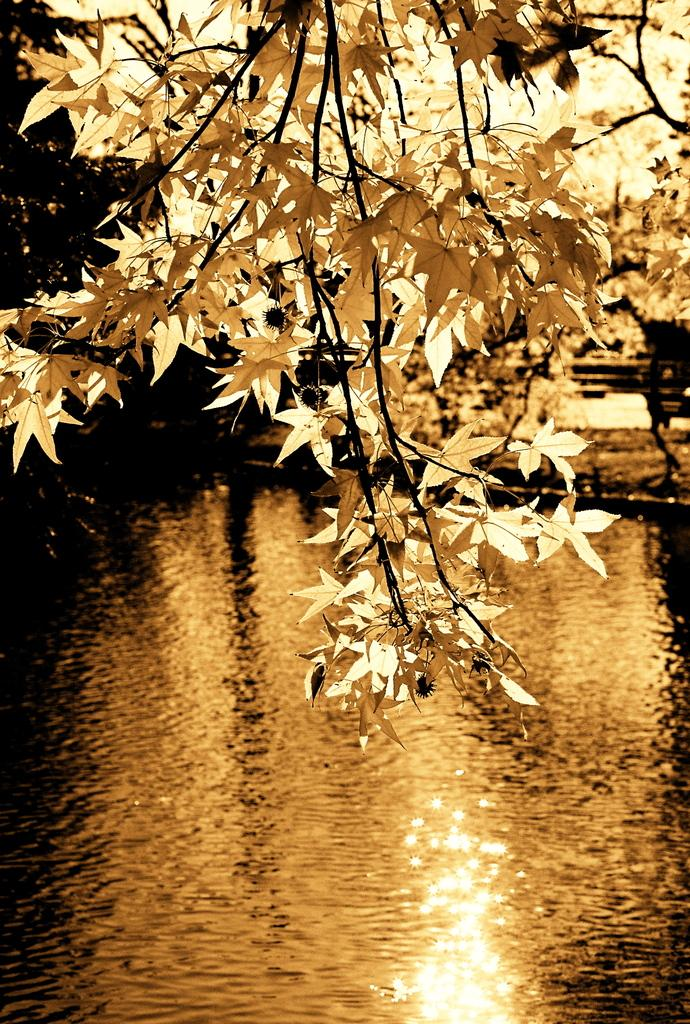What is the main feature in the image? There is a lake in the image. Where is the lake located in relation to the image? The lake is in the front of the image. What can be observed on the surface of the lake? There is sun reflection on the lake. What type of vegetation is visible near the lake? There are trees above the lake. What committee is responsible for maintaining the route to the lake in the image? There is no committee or route mentioned in the image; it simply shows a lake with sun reflection and trees above it. 